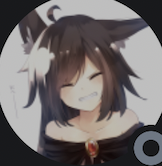who is this
 This is an anime-style drawing of a young woman with cat ears. She has black hair and blue eyes. She is wearing a black dress with a white collar. 